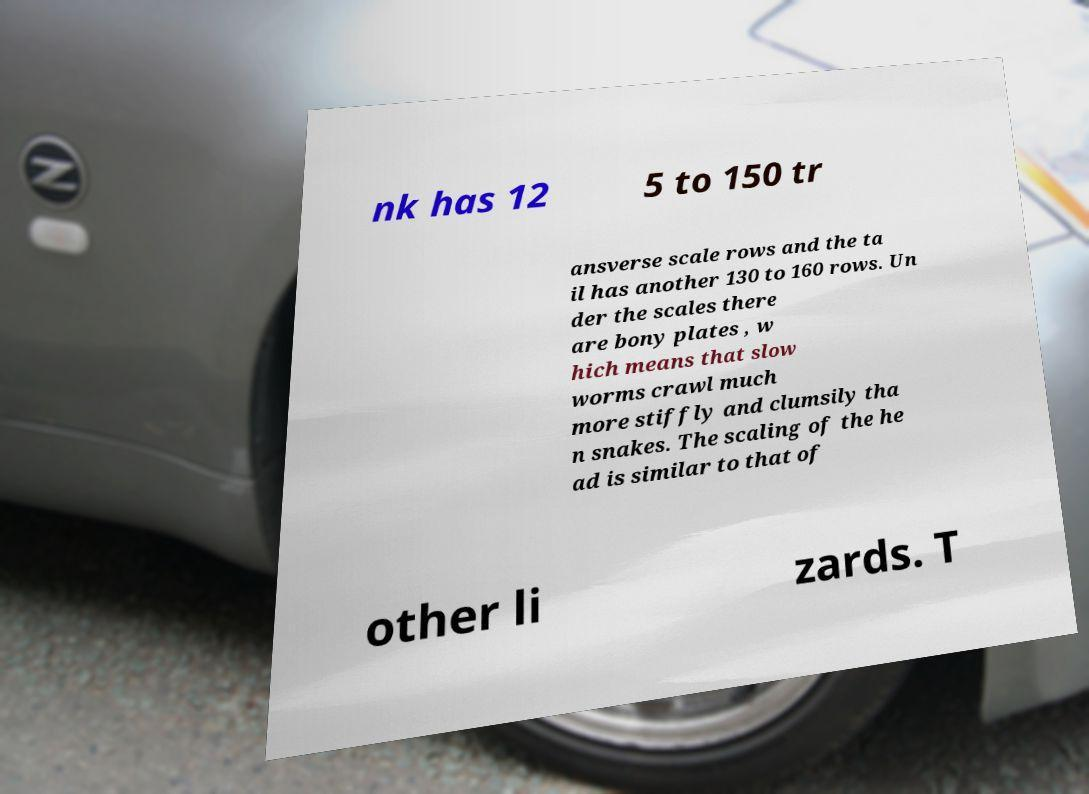Can you accurately transcribe the text from the provided image for me? nk has 12 5 to 150 tr ansverse scale rows and the ta il has another 130 to 160 rows. Un der the scales there are bony plates , w hich means that slow worms crawl much more stiffly and clumsily tha n snakes. The scaling of the he ad is similar to that of other li zards. T 